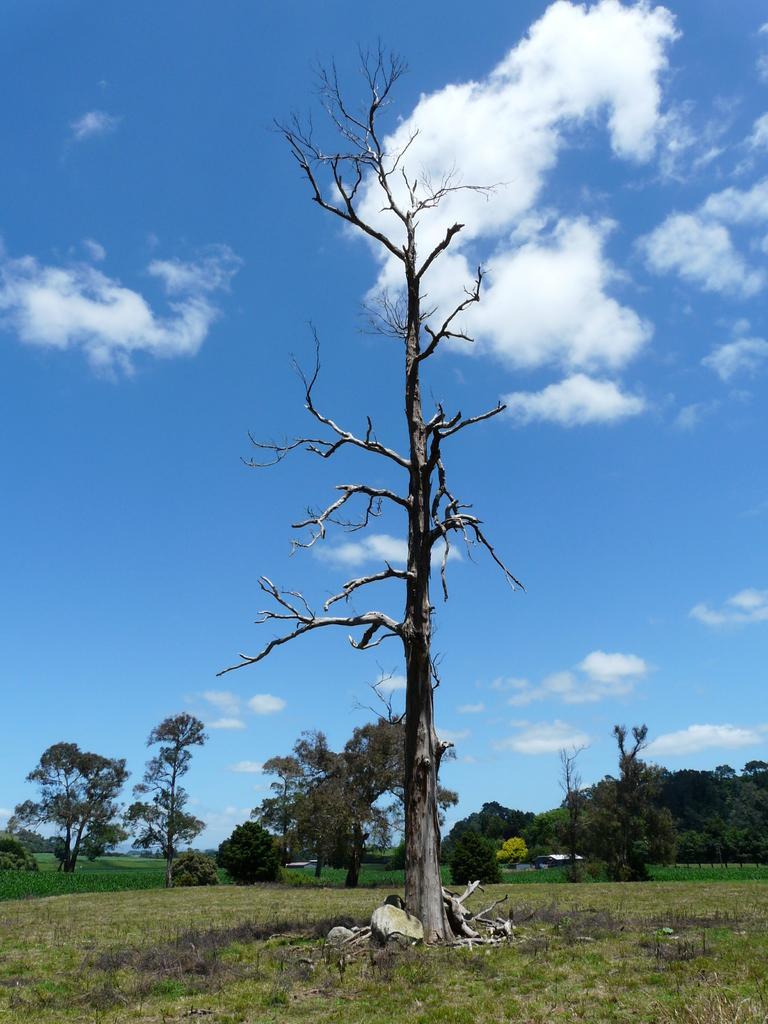Please provide a concise description of this image. In this image we can see a dry tree on the grassy land. Background of the image trees are there and sky is present with little clouds. 